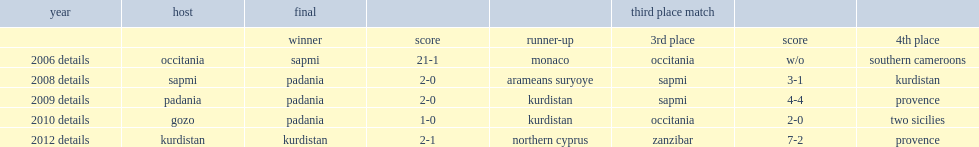Can you give me this table as a dict? {'header': ['year', 'host', 'final', '', '', 'third place match', '', ''], 'rows': [['', '', 'winner', 'score', 'runner-up', '3rd place', 'score', '4th place'], ['2006 details', 'occitania', 'sapmi', '21-1', 'monaco', 'occitania', 'w/o', 'southern cameroons'], ['2008 details', 'sapmi', 'padania', '2-0', 'arameans suryoye', 'sapmi', '3-1', 'kurdistan'], ['2009 details', 'padania', 'padania', '2-0', 'kurdistan', 'sapmi', '4-4', 'provence'], ['2010 details', 'gozo', 'padania', '1-0', 'kurdistan', 'occitania', '2-0', 'two sicilies'], ['2012 details', 'kurdistan', 'kurdistan', '2-1', 'northern cyprus', 'zanzibar', '7-2', 'provence']]} What is the final result for the first viva world cup? 21-1. 